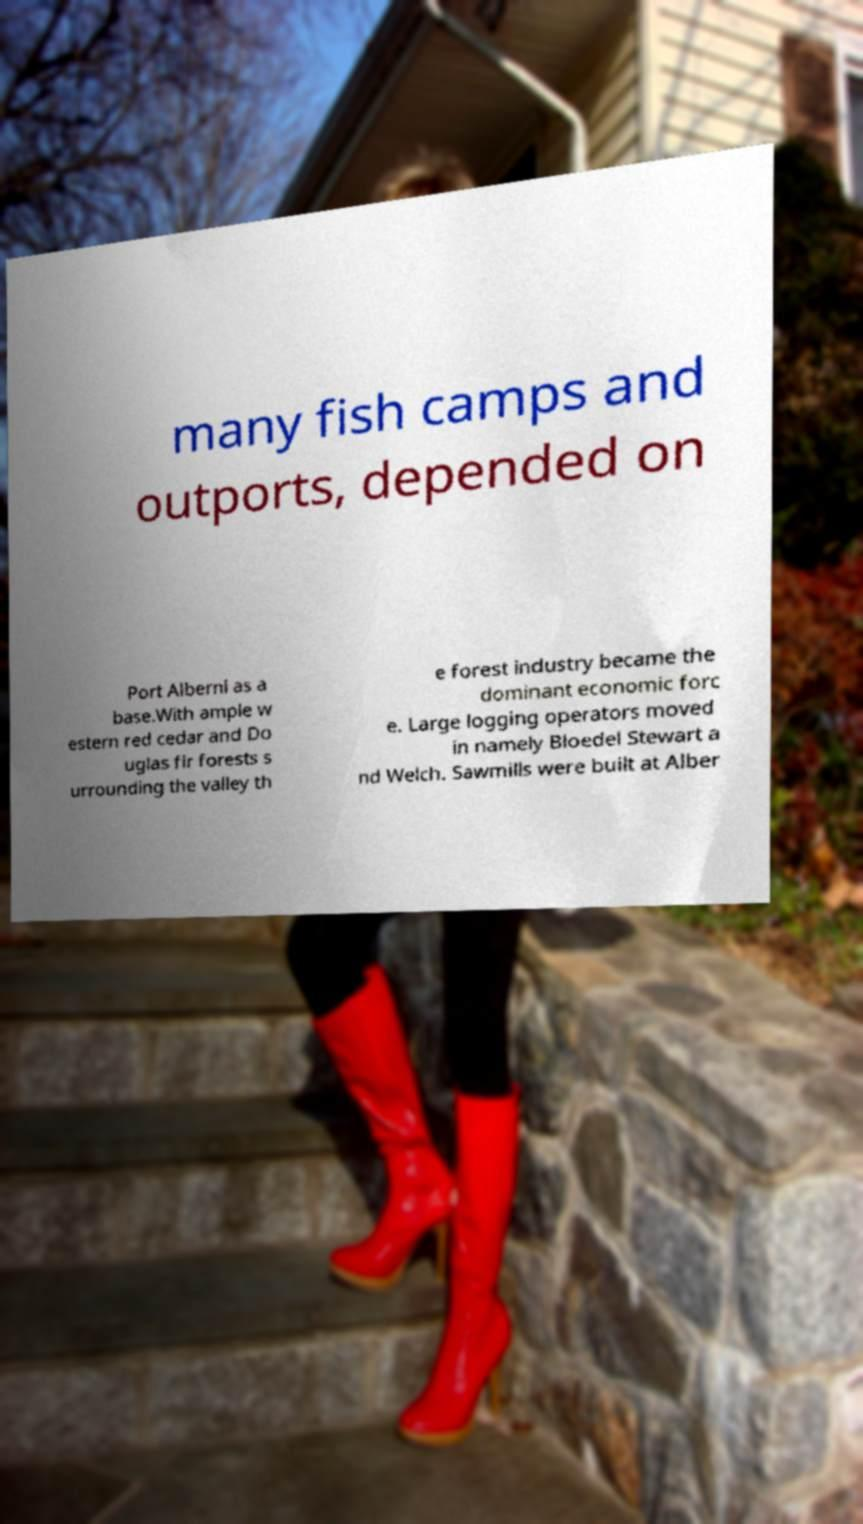Can you accurately transcribe the text from the provided image for me? many fish camps and outports, depended on Port Alberni as a base.With ample w estern red cedar and Do uglas fir forests s urrounding the valley th e forest industry became the dominant economic forc e. Large logging operators moved in namely Bloedel Stewart a nd Welch. Sawmills were built at Alber 